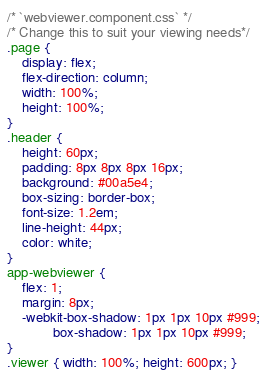<code> <loc_0><loc_0><loc_500><loc_500><_CSS_>/* `webviewer.component.css` */
/* Change this to suit your viewing needs*/
.page {
    display: flex;
    flex-direction: column;
    width: 100%;
    height: 100%;
}
.header {
    height: 60px;
    padding: 8px 8px 8px 16px;
    background: #00a5e4;
    box-sizing: border-box;
    font-size: 1.2em;
    line-height: 44px;
    color: white;
}
app-webviewer {
    flex: 1;
    margin: 8px;
    -webkit-box-shadow: 1px 1px 10px #999;
            box-shadow: 1px 1px 10px #999;
}
.viewer { width: 100%; height: 600px; }</code> 